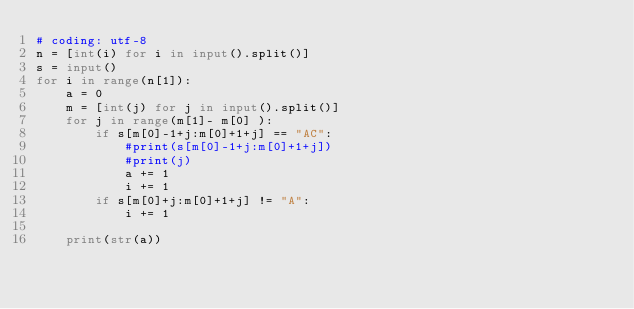Convert code to text. <code><loc_0><loc_0><loc_500><loc_500><_Python_># coding: utf-8
n = [int(i) for i in input().split()]
s = input()
for i in range(n[1]):
    a = 0
    m = [int(j) for j in input().split()]
    for j in range(m[1]- m[0] ):
        if s[m[0]-1+j:m[0]+1+j] == "AC":
            #print(s[m[0]-1+j:m[0]+1+j])
            #print(j)
            a += 1
            i += 1
        if s[m[0]+j:m[0]+1+j] != "A":
            i += 1
            
    print(str(a))</code> 